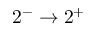Convert formula to latex. <formula><loc_0><loc_0><loc_500><loc_500>2 ^ { - } \rightarrow 2 ^ { + }</formula> 